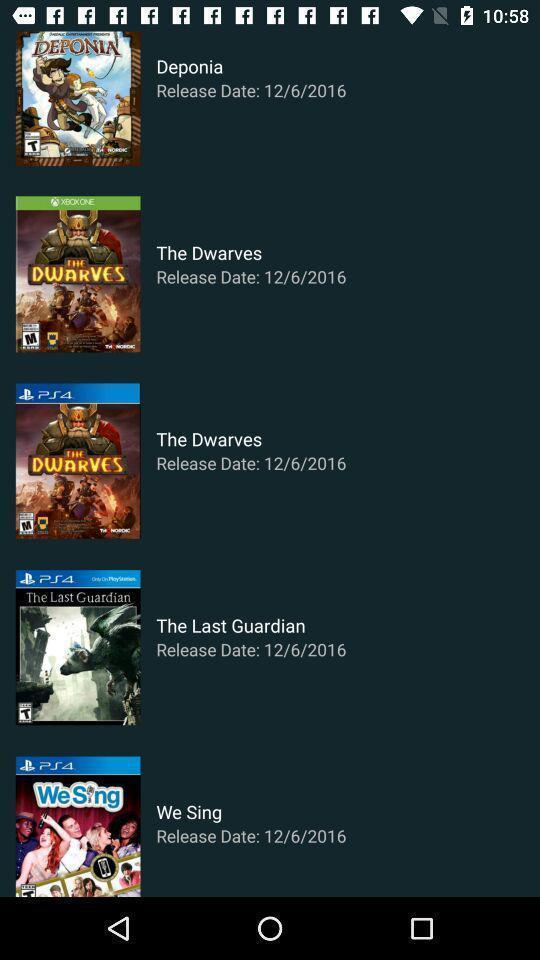Describe the visual elements of this screenshot. Screen showing movies with release date. 